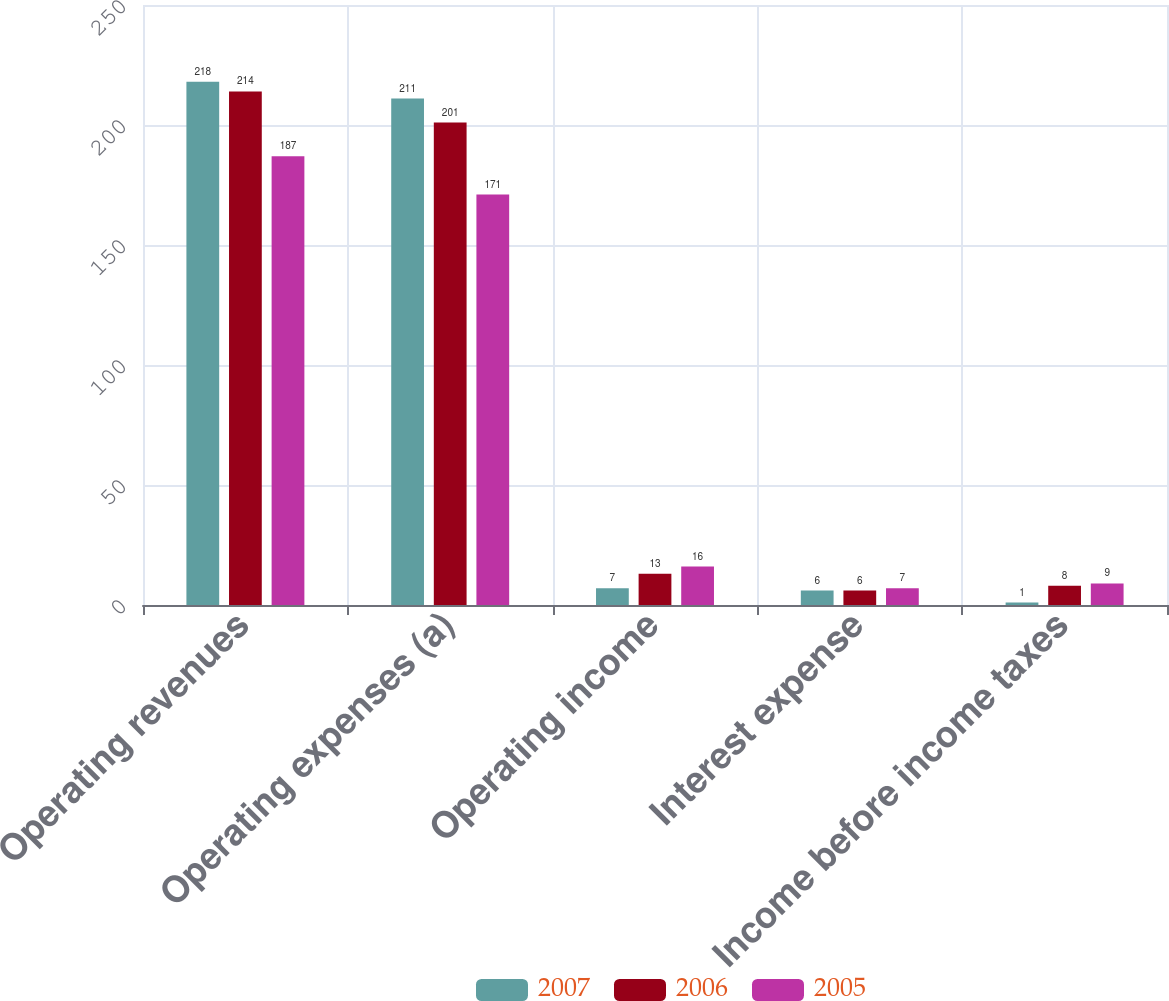<chart> <loc_0><loc_0><loc_500><loc_500><stacked_bar_chart><ecel><fcel>Operating revenues<fcel>Operating expenses (a)<fcel>Operating income<fcel>Interest expense<fcel>Income before income taxes<nl><fcel>2007<fcel>218<fcel>211<fcel>7<fcel>6<fcel>1<nl><fcel>2006<fcel>214<fcel>201<fcel>13<fcel>6<fcel>8<nl><fcel>2005<fcel>187<fcel>171<fcel>16<fcel>7<fcel>9<nl></chart> 